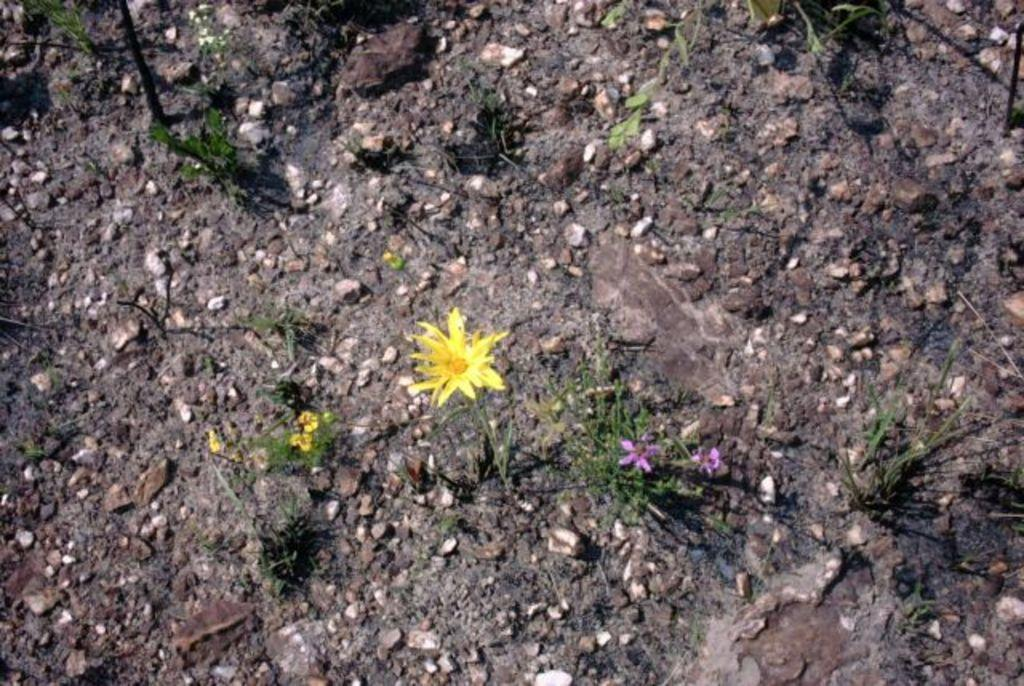What type of living organisms can be seen in the image? Plants can be seen in the image. What can be found on the ground in the image? There are stones and rocks on the ground in the image. What type of lamp is hanging from the circle in the image? There is no lamp or circle present in the image. 